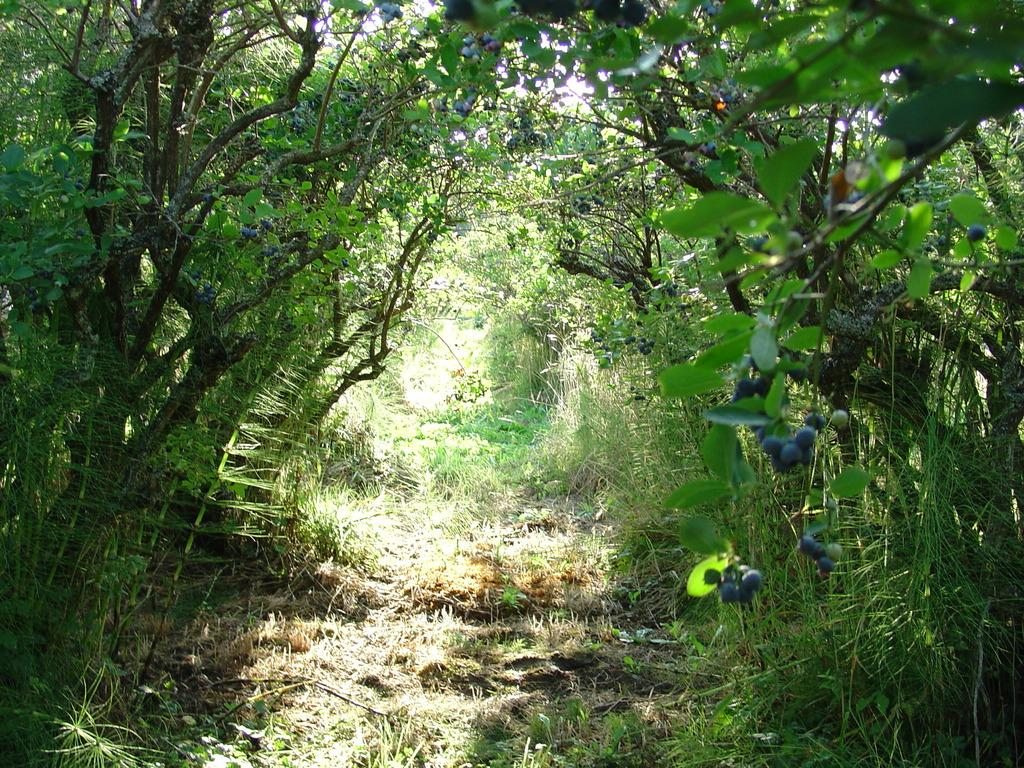What type of vegetation can be seen in the image? There are trees and flowers on plants in the image. Where are the flowers located in the image? The flowers are on the right side of the image. What is the condition of the ground in the image? There is dry grass on the ground in the image. What is the level of wealth depicted in the image? There is no indication of wealth in the image; it features trees, flowers, and dry grass. What type of weather can be inferred from the image? The image does not provide enough information to determine the weather; it only shows trees, flowers, and dry grass. 